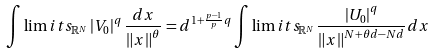<formula> <loc_0><loc_0><loc_500><loc_500>\int \lim i t s _ { \mathbb { R } ^ { N } } \left | V _ { 0 } \right | ^ { q } \frac { d x } { \left \| x \right \| ^ { \theta } } = d ^ { 1 + \frac { p - 1 } { p } q } \int \lim i t s _ { \mathbb { R } ^ { N } } \frac { \left | U _ { 0 } \right | ^ { q } } { \left \| x \right \| ^ { N + \theta d - N d } } d x</formula> 